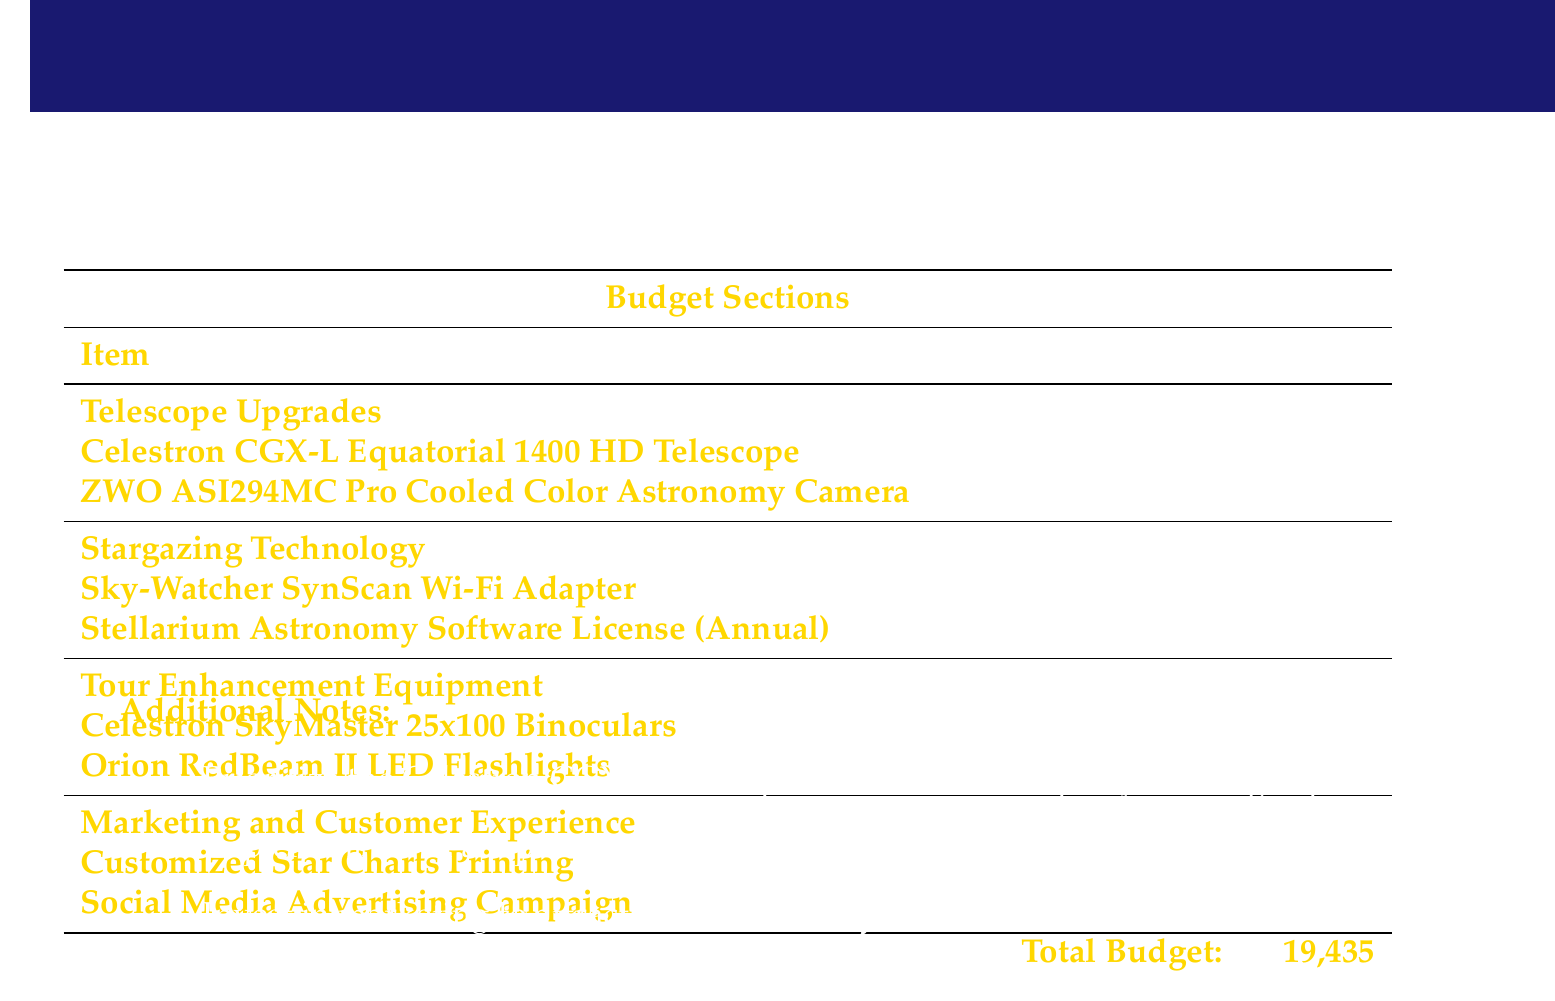What is the total budget? The total budget is stated at the bottom of the budget table and includes all expenses listed.
Answer: 19,435 How many Celestron CGX-L telescopes are being purchased? The document lists the quantity of Celestron CGX-L telescopes as one under the telescope upgrades section.
Answer: 1 What is the cost of the ZWO ASI294MC Pro camera? The cost for each ZWO ASI294MC Pro camera is specified in the budget table under telescope upgrades.
Answer: 999 How many Orion RedBeam II LED flashlights are included in the budget? The quantity for Orion RedBeam II LED flashlights is mentioned under the tour enhancement equipment section.
Answer: 10 What is the cost of the Stellarium Astronomy Software License? The cost per unit for the Stellarium Astronomy Software License is provided in the budget section for stargazing technology.
Answer: 39 What is the primary focus of the additional notes? The additional notes discuss the priorities regarding upgrades and marketing strategies for astronomy tours.
Answer: Prioritize the Celestron CGX-L How many total items are listed under tour enhancement equipment? The budget section for tour enhancement equipment indicates the total items listed.
Answer: 2 What is the total cost for the Customized Star Charts Printing? The cost for Customized Star Charts Printing is explicitly mentioned under the marketing section of the budget.
Answer: 500 How much is allocated for the Social Media Advertising Campaign? The document specifies the budget allocated for the Social Media Advertising Campaign.
Answer: 1,000 What is the quantity of Sky-Watcher SynScan Wi-Fi Adapters included? The number of Sky-Watcher SynScan Wi-Fi Adapters is stated in the stargazing technology section.
Answer: 3 